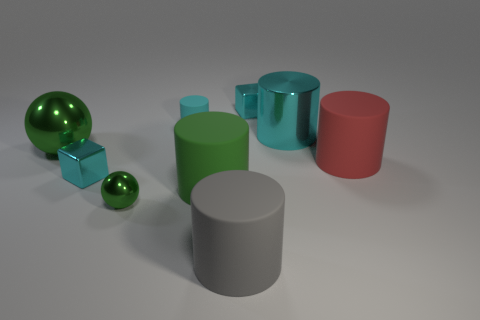Subtract all large matte cylinders. How many cylinders are left? 2 Subtract all purple cubes. How many cyan cylinders are left? 2 Add 1 large green cylinders. How many objects exist? 10 Subtract all gray cylinders. How many cylinders are left? 4 Subtract 3 cylinders. How many cylinders are left? 2 Subtract all blocks. How many objects are left? 7 Subtract 0 blue cylinders. How many objects are left? 9 Subtract all blue cylinders. Subtract all gray balls. How many cylinders are left? 5 Subtract all big objects. Subtract all tiny blocks. How many objects are left? 2 Add 5 big matte objects. How many big matte objects are left? 8 